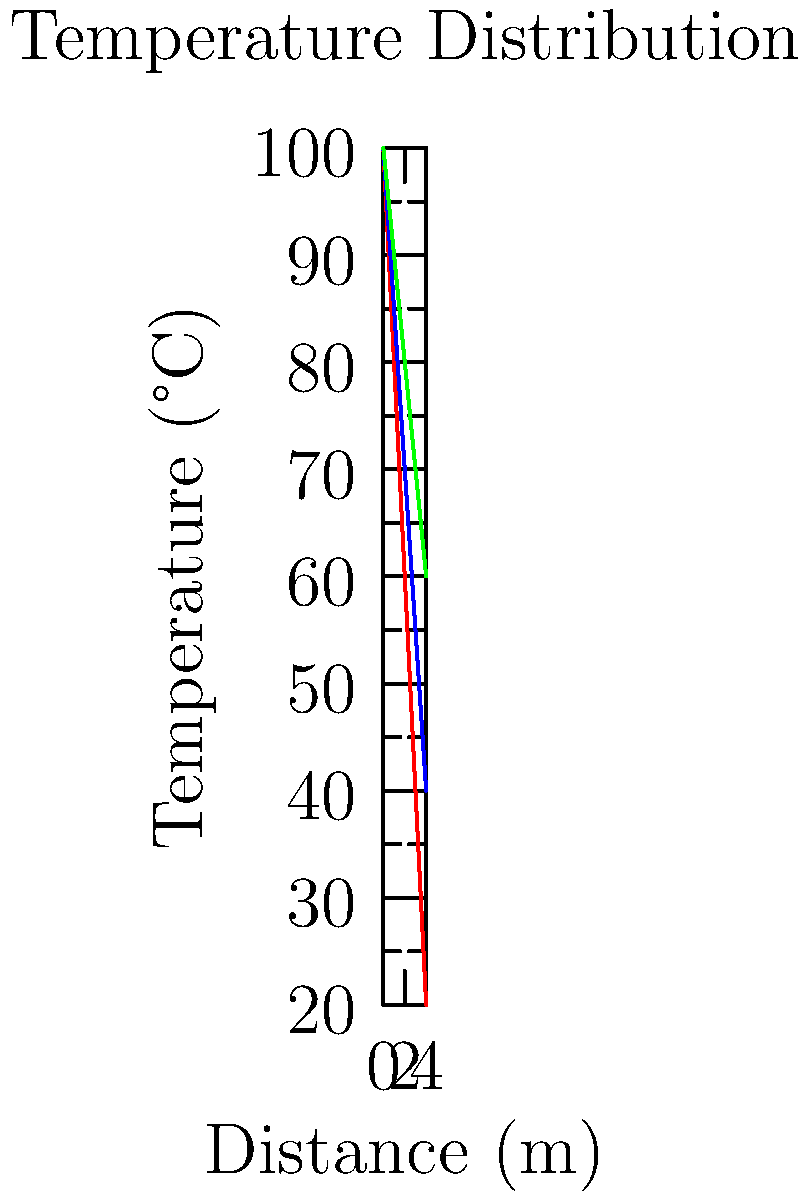As someone who has learned the importance of thorough research, you're now studying heat transfer in different materials. The graph shows temperature distributions across three materials of equal thickness. Which material has the highest thermal conductivity, and what does this imply about its heat transfer rate? To determine which material has the highest thermal conductivity and heat transfer rate, we need to analyze the temperature gradients:

1. Recall Fourier's Law of Heat Conduction: $q = -k \frac{dT}{dx}$
   Where $q$ is heat flux, $k$ is thermal conductivity, and $\frac{dT}{dx}$ is the temperature gradient.

2. Observe the slopes of the temperature distributions:
   - Material A (red) has the steepest slope
   - Material B (blue) has a moderate slope
   - Material C (green) has the shallowest slope

3. A steeper slope indicates a larger temperature gradient $\frac{dT}{dx}$.

4. For the same heat flux $q$, a larger $\frac{dT}{dx}$ implies a smaller $k$ (thermal conductivity).

5. Therefore, Material C (green) with the shallowest slope has the highest thermal conductivity.

6. Higher thermal conductivity means:
   $$q = -k \frac{dT}{dx}$$
   For the same temperature gradient, a larger $k$ results in a larger $q$ (heat flux).

7. Thus, Material C will have the highest heat transfer rate for a given temperature difference.
Answer: Material C; highest heat transfer rate 